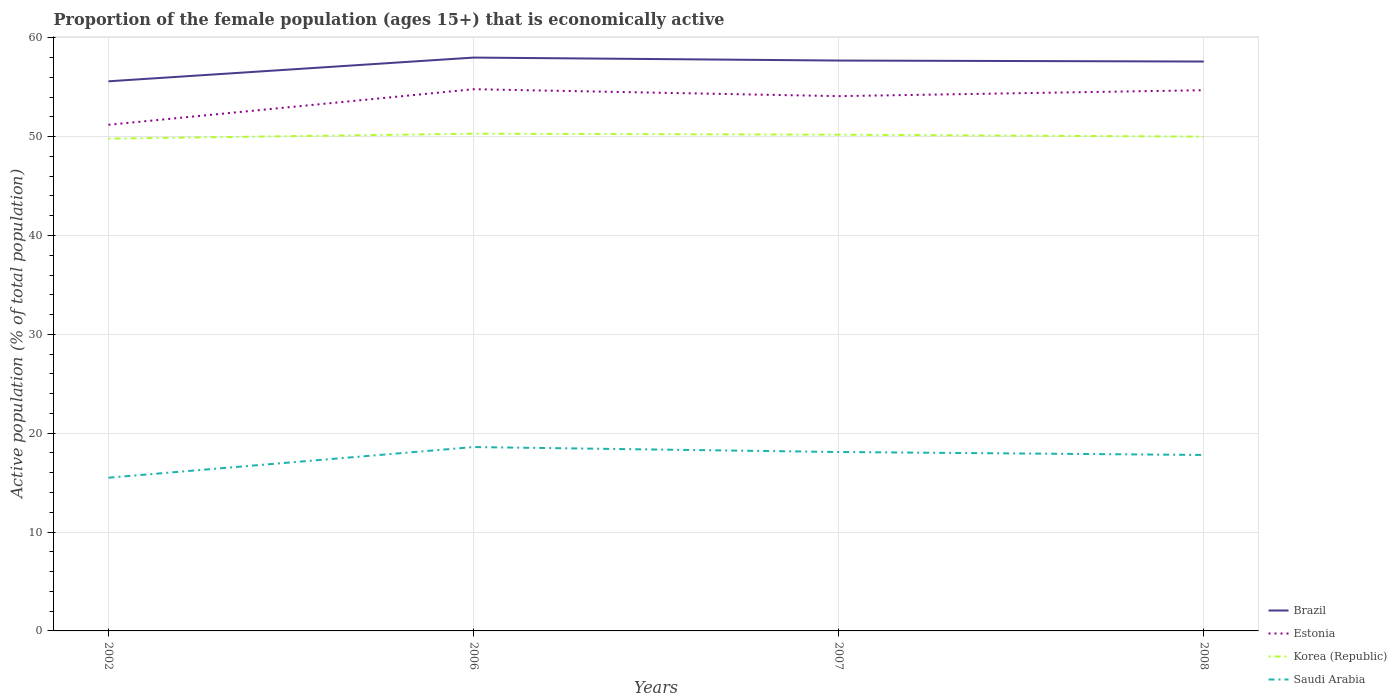How many different coloured lines are there?
Provide a succinct answer. 4. Does the line corresponding to Estonia intersect with the line corresponding to Saudi Arabia?
Provide a succinct answer. No. Across all years, what is the maximum proportion of the female population that is economically active in Brazil?
Keep it short and to the point. 55.6. In which year was the proportion of the female population that is economically active in Saudi Arabia maximum?
Give a very brief answer. 2002. What is the difference between the highest and the second highest proportion of the female population that is economically active in Brazil?
Your answer should be very brief. 2.4. What is the difference between the highest and the lowest proportion of the female population that is economically active in Korea (Republic)?
Offer a very short reply. 2. Is the proportion of the female population that is economically active in Saudi Arabia strictly greater than the proportion of the female population that is economically active in Estonia over the years?
Ensure brevity in your answer.  Yes. How many years are there in the graph?
Provide a succinct answer. 4. What is the difference between two consecutive major ticks on the Y-axis?
Your answer should be compact. 10. Does the graph contain grids?
Your response must be concise. Yes. Where does the legend appear in the graph?
Ensure brevity in your answer.  Bottom right. What is the title of the graph?
Your answer should be very brief. Proportion of the female population (ages 15+) that is economically active. What is the label or title of the X-axis?
Your answer should be compact. Years. What is the label or title of the Y-axis?
Give a very brief answer. Active population (% of total population). What is the Active population (% of total population) in Brazil in 2002?
Offer a terse response. 55.6. What is the Active population (% of total population) in Estonia in 2002?
Keep it short and to the point. 51.2. What is the Active population (% of total population) of Korea (Republic) in 2002?
Keep it short and to the point. 49.8. What is the Active population (% of total population) in Saudi Arabia in 2002?
Make the answer very short. 15.5. What is the Active population (% of total population) of Estonia in 2006?
Ensure brevity in your answer.  54.8. What is the Active population (% of total population) in Korea (Republic) in 2006?
Make the answer very short. 50.3. What is the Active population (% of total population) in Saudi Arabia in 2006?
Keep it short and to the point. 18.6. What is the Active population (% of total population) in Brazil in 2007?
Give a very brief answer. 57.7. What is the Active population (% of total population) of Estonia in 2007?
Ensure brevity in your answer.  54.1. What is the Active population (% of total population) in Korea (Republic) in 2007?
Provide a succinct answer. 50.2. What is the Active population (% of total population) of Saudi Arabia in 2007?
Provide a succinct answer. 18.1. What is the Active population (% of total population) in Brazil in 2008?
Provide a short and direct response. 57.6. What is the Active population (% of total population) in Estonia in 2008?
Your answer should be very brief. 54.7. What is the Active population (% of total population) of Korea (Republic) in 2008?
Give a very brief answer. 50. What is the Active population (% of total population) in Saudi Arabia in 2008?
Your response must be concise. 17.8. Across all years, what is the maximum Active population (% of total population) in Estonia?
Give a very brief answer. 54.8. Across all years, what is the maximum Active population (% of total population) of Korea (Republic)?
Your answer should be very brief. 50.3. Across all years, what is the maximum Active population (% of total population) in Saudi Arabia?
Keep it short and to the point. 18.6. Across all years, what is the minimum Active population (% of total population) in Brazil?
Your answer should be compact. 55.6. Across all years, what is the minimum Active population (% of total population) of Estonia?
Ensure brevity in your answer.  51.2. Across all years, what is the minimum Active population (% of total population) in Korea (Republic)?
Offer a very short reply. 49.8. What is the total Active population (% of total population) of Brazil in the graph?
Keep it short and to the point. 228.9. What is the total Active population (% of total population) in Estonia in the graph?
Your answer should be compact. 214.8. What is the total Active population (% of total population) in Korea (Republic) in the graph?
Offer a very short reply. 200.3. What is the total Active population (% of total population) of Saudi Arabia in the graph?
Provide a short and direct response. 70. What is the difference between the Active population (% of total population) in Brazil in 2002 and that in 2006?
Your answer should be compact. -2.4. What is the difference between the Active population (% of total population) in Saudi Arabia in 2002 and that in 2006?
Make the answer very short. -3.1. What is the difference between the Active population (% of total population) of Brazil in 2002 and that in 2007?
Provide a short and direct response. -2.1. What is the difference between the Active population (% of total population) of Saudi Arabia in 2002 and that in 2007?
Keep it short and to the point. -2.6. What is the difference between the Active population (% of total population) of Brazil in 2002 and that in 2008?
Your response must be concise. -2. What is the difference between the Active population (% of total population) in Estonia in 2002 and that in 2008?
Give a very brief answer. -3.5. What is the difference between the Active population (% of total population) in Brazil in 2006 and that in 2007?
Make the answer very short. 0.3. What is the difference between the Active population (% of total population) in Estonia in 2006 and that in 2007?
Provide a succinct answer. 0.7. What is the difference between the Active population (% of total population) in Saudi Arabia in 2006 and that in 2008?
Offer a terse response. 0.8. What is the difference between the Active population (% of total population) in Brazil in 2007 and that in 2008?
Make the answer very short. 0.1. What is the difference between the Active population (% of total population) of Estonia in 2002 and the Active population (% of total population) of Saudi Arabia in 2006?
Give a very brief answer. 32.6. What is the difference between the Active population (% of total population) in Korea (Republic) in 2002 and the Active population (% of total population) in Saudi Arabia in 2006?
Your response must be concise. 31.2. What is the difference between the Active population (% of total population) of Brazil in 2002 and the Active population (% of total population) of Estonia in 2007?
Offer a terse response. 1.5. What is the difference between the Active population (% of total population) in Brazil in 2002 and the Active population (% of total population) in Saudi Arabia in 2007?
Give a very brief answer. 37.5. What is the difference between the Active population (% of total population) of Estonia in 2002 and the Active population (% of total population) of Saudi Arabia in 2007?
Make the answer very short. 33.1. What is the difference between the Active population (% of total population) in Korea (Republic) in 2002 and the Active population (% of total population) in Saudi Arabia in 2007?
Your answer should be very brief. 31.7. What is the difference between the Active population (% of total population) in Brazil in 2002 and the Active population (% of total population) in Estonia in 2008?
Keep it short and to the point. 0.9. What is the difference between the Active population (% of total population) in Brazil in 2002 and the Active population (% of total population) in Saudi Arabia in 2008?
Your answer should be very brief. 37.8. What is the difference between the Active population (% of total population) in Estonia in 2002 and the Active population (% of total population) in Saudi Arabia in 2008?
Your response must be concise. 33.4. What is the difference between the Active population (% of total population) in Brazil in 2006 and the Active population (% of total population) in Estonia in 2007?
Your answer should be compact. 3.9. What is the difference between the Active population (% of total population) in Brazil in 2006 and the Active population (% of total population) in Korea (Republic) in 2007?
Your answer should be compact. 7.8. What is the difference between the Active population (% of total population) of Brazil in 2006 and the Active population (% of total population) of Saudi Arabia in 2007?
Your response must be concise. 39.9. What is the difference between the Active population (% of total population) of Estonia in 2006 and the Active population (% of total population) of Korea (Republic) in 2007?
Give a very brief answer. 4.6. What is the difference between the Active population (% of total population) in Estonia in 2006 and the Active population (% of total population) in Saudi Arabia in 2007?
Ensure brevity in your answer.  36.7. What is the difference between the Active population (% of total population) of Korea (Republic) in 2006 and the Active population (% of total population) of Saudi Arabia in 2007?
Give a very brief answer. 32.2. What is the difference between the Active population (% of total population) in Brazil in 2006 and the Active population (% of total population) in Estonia in 2008?
Your answer should be very brief. 3.3. What is the difference between the Active population (% of total population) of Brazil in 2006 and the Active population (% of total population) of Saudi Arabia in 2008?
Your answer should be compact. 40.2. What is the difference between the Active population (% of total population) of Estonia in 2006 and the Active population (% of total population) of Korea (Republic) in 2008?
Your answer should be compact. 4.8. What is the difference between the Active population (% of total population) of Korea (Republic) in 2006 and the Active population (% of total population) of Saudi Arabia in 2008?
Offer a terse response. 32.5. What is the difference between the Active population (% of total population) in Brazil in 2007 and the Active population (% of total population) in Saudi Arabia in 2008?
Make the answer very short. 39.9. What is the difference between the Active population (% of total population) in Estonia in 2007 and the Active population (% of total population) in Saudi Arabia in 2008?
Your response must be concise. 36.3. What is the difference between the Active population (% of total population) of Korea (Republic) in 2007 and the Active population (% of total population) of Saudi Arabia in 2008?
Provide a succinct answer. 32.4. What is the average Active population (% of total population) in Brazil per year?
Provide a short and direct response. 57.23. What is the average Active population (% of total population) in Estonia per year?
Ensure brevity in your answer.  53.7. What is the average Active population (% of total population) of Korea (Republic) per year?
Offer a very short reply. 50.08. In the year 2002, what is the difference between the Active population (% of total population) of Brazil and Active population (% of total population) of Korea (Republic)?
Keep it short and to the point. 5.8. In the year 2002, what is the difference between the Active population (% of total population) in Brazil and Active population (% of total population) in Saudi Arabia?
Offer a terse response. 40.1. In the year 2002, what is the difference between the Active population (% of total population) in Estonia and Active population (% of total population) in Korea (Republic)?
Ensure brevity in your answer.  1.4. In the year 2002, what is the difference between the Active population (% of total population) in Estonia and Active population (% of total population) in Saudi Arabia?
Offer a terse response. 35.7. In the year 2002, what is the difference between the Active population (% of total population) in Korea (Republic) and Active population (% of total population) in Saudi Arabia?
Offer a very short reply. 34.3. In the year 2006, what is the difference between the Active population (% of total population) of Brazil and Active population (% of total population) of Korea (Republic)?
Your answer should be compact. 7.7. In the year 2006, what is the difference between the Active population (% of total population) in Brazil and Active population (% of total population) in Saudi Arabia?
Ensure brevity in your answer.  39.4. In the year 2006, what is the difference between the Active population (% of total population) of Estonia and Active population (% of total population) of Saudi Arabia?
Your response must be concise. 36.2. In the year 2006, what is the difference between the Active population (% of total population) in Korea (Republic) and Active population (% of total population) in Saudi Arabia?
Provide a short and direct response. 31.7. In the year 2007, what is the difference between the Active population (% of total population) in Brazil and Active population (% of total population) in Korea (Republic)?
Your response must be concise. 7.5. In the year 2007, what is the difference between the Active population (% of total population) in Brazil and Active population (% of total population) in Saudi Arabia?
Your answer should be very brief. 39.6. In the year 2007, what is the difference between the Active population (% of total population) in Estonia and Active population (% of total population) in Saudi Arabia?
Provide a succinct answer. 36. In the year 2007, what is the difference between the Active population (% of total population) of Korea (Republic) and Active population (% of total population) of Saudi Arabia?
Make the answer very short. 32.1. In the year 2008, what is the difference between the Active population (% of total population) in Brazil and Active population (% of total population) in Estonia?
Make the answer very short. 2.9. In the year 2008, what is the difference between the Active population (% of total population) in Brazil and Active population (% of total population) in Korea (Republic)?
Offer a very short reply. 7.6. In the year 2008, what is the difference between the Active population (% of total population) in Brazil and Active population (% of total population) in Saudi Arabia?
Provide a succinct answer. 39.8. In the year 2008, what is the difference between the Active population (% of total population) in Estonia and Active population (% of total population) in Saudi Arabia?
Your answer should be very brief. 36.9. In the year 2008, what is the difference between the Active population (% of total population) of Korea (Republic) and Active population (% of total population) of Saudi Arabia?
Provide a short and direct response. 32.2. What is the ratio of the Active population (% of total population) in Brazil in 2002 to that in 2006?
Ensure brevity in your answer.  0.96. What is the ratio of the Active population (% of total population) in Estonia in 2002 to that in 2006?
Your answer should be very brief. 0.93. What is the ratio of the Active population (% of total population) of Korea (Republic) in 2002 to that in 2006?
Provide a short and direct response. 0.99. What is the ratio of the Active population (% of total population) of Saudi Arabia in 2002 to that in 2006?
Give a very brief answer. 0.83. What is the ratio of the Active population (% of total population) of Brazil in 2002 to that in 2007?
Offer a terse response. 0.96. What is the ratio of the Active population (% of total population) in Estonia in 2002 to that in 2007?
Give a very brief answer. 0.95. What is the ratio of the Active population (% of total population) in Saudi Arabia in 2002 to that in 2007?
Keep it short and to the point. 0.86. What is the ratio of the Active population (% of total population) in Brazil in 2002 to that in 2008?
Your response must be concise. 0.97. What is the ratio of the Active population (% of total population) in Estonia in 2002 to that in 2008?
Make the answer very short. 0.94. What is the ratio of the Active population (% of total population) in Korea (Republic) in 2002 to that in 2008?
Make the answer very short. 1. What is the ratio of the Active population (% of total population) in Saudi Arabia in 2002 to that in 2008?
Your answer should be very brief. 0.87. What is the ratio of the Active population (% of total population) of Estonia in 2006 to that in 2007?
Offer a very short reply. 1.01. What is the ratio of the Active population (% of total population) in Korea (Republic) in 2006 to that in 2007?
Offer a very short reply. 1. What is the ratio of the Active population (% of total population) in Saudi Arabia in 2006 to that in 2007?
Your response must be concise. 1.03. What is the ratio of the Active population (% of total population) in Brazil in 2006 to that in 2008?
Keep it short and to the point. 1.01. What is the ratio of the Active population (% of total population) in Saudi Arabia in 2006 to that in 2008?
Your answer should be compact. 1.04. What is the ratio of the Active population (% of total population) in Brazil in 2007 to that in 2008?
Your answer should be very brief. 1. What is the ratio of the Active population (% of total population) in Estonia in 2007 to that in 2008?
Offer a very short reply. 0.99. What is the ratio of the Active population (% of total population) of Korea (Republic) in 2007 to that in 2008?
Your answer should be compact. 1. What is the ratio of the Active population (% of total population) in Saudi Arabia in 2007 to that in 2008?
Offer a terse response. 1.02. What is the difference between the highest and the second highest Active population (% of total population) of Estonia?
Give a very brief answer. 0.1. What is the difference between the highest and the second highest Active population (% of total population) of Saudi Arabia?
Offer a very short reply. 0.5. What is the difference between the highest and the lowest Active population (% of total population) of Brazil?
Your answer should be compact. 2.4. What is the difference between the highest and the lowest Active population (% of total population) of Saudi Arabia?
Your response must be concise. 3.1. 